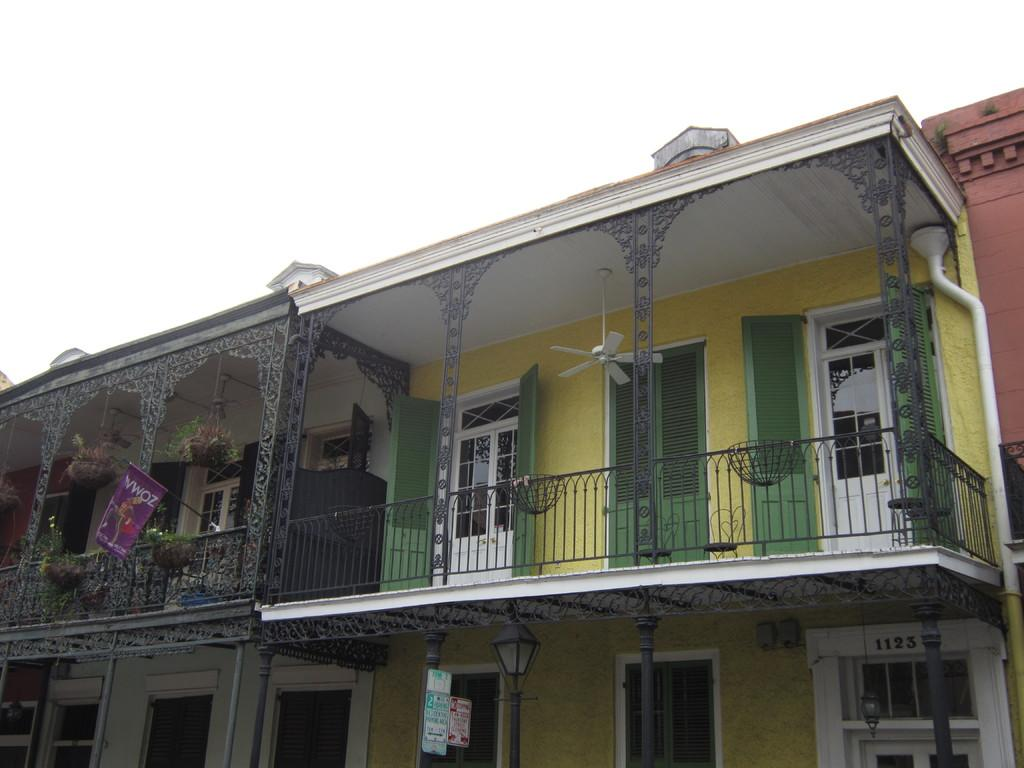What type of structures can be seen in the image? There are buildings in the image. What object is present for air circulation? There is a fan in the image. What architectural features are visible in the image? There are windows and a door in the image. What type of cooking appliances can be seen in the image? There are grills in the image. What symbol or emblem is present in the image? There is a flag in the image. What type of vegetation is present in the image? There are plants in the image. What type of lighting is present in the image? There is an electric light in the image. What type of vertical supports are present in the image? There are poles in the image. What is visible at the top of the image? The sky is visible at the top of the image. Can you tell me how many veins are visible in the image? There are no veins present in the image. What type of things are being cooked on the grills in the image? The image does not show any specific things being cooked on the grills. 